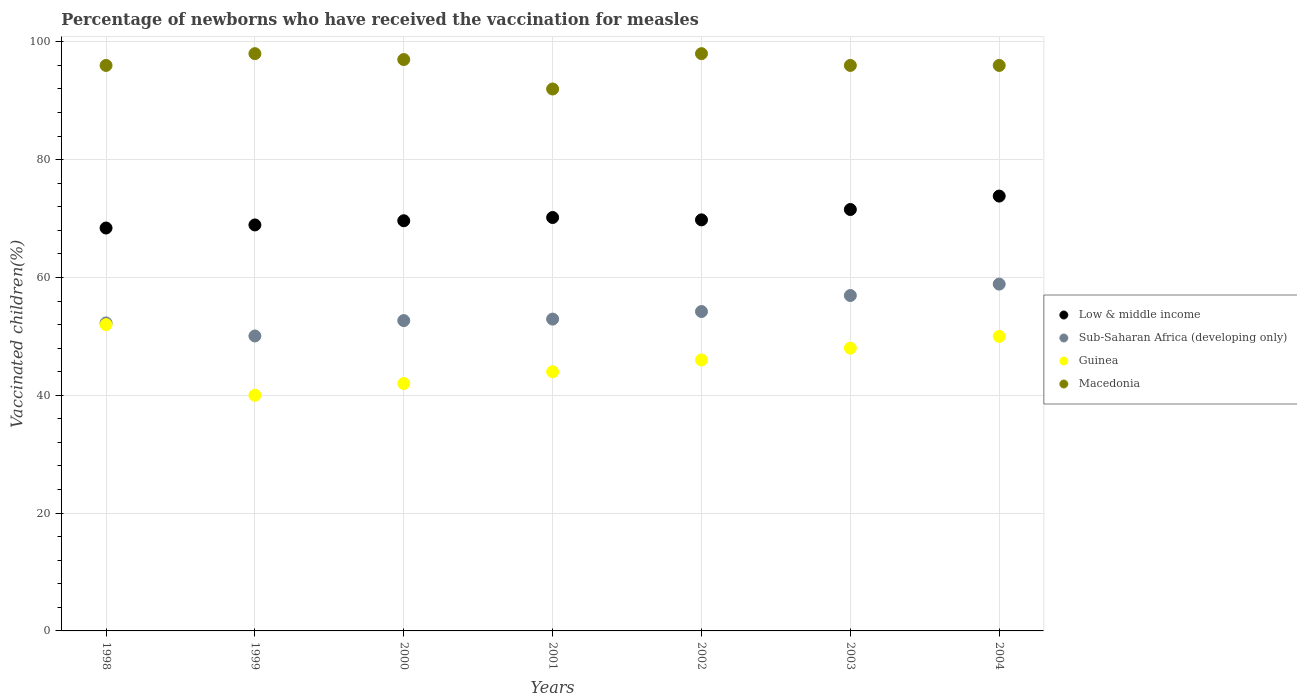How many different coloured dotlines are there?
Ensure brevity in your answer.  4. Is the number of dotlines equal to the number of legend labels?
Keep it short and to the point. Yes. What is the percentage of vaccinated children in Sub-Saharan Africa (developing only) in 1998?
Offer a very short reply. 52.28. Across all years, what is the maximum percentage of vaccinated children in Low & middle income?
Offer a very short reply. 73.82. Across all years, what is the minimum percentage of vaccinated children in Macedonia?
Your answer should be very brief. 92. What is the total percentage of vaccinated children in Sub-Saharan Africa (developing only) in the graph?
Offer a terse response. 378.02. What is the difference between the percentage of vaccinated children in Sub-Saharan Africa (developing only) in 1998 and that in 2000?
Your answer should be compact. -0.4. What is the difference between the percentage of vaccinated children in Guinea in 2004 and the percentage of vaccinated children in Sub-Saharan Africa (developing only) in 2001?
Your answer should be compact. -2.94. In the year 2004, what is the difference between the percentage of vaccinated children in Guinea and percentage of vaccinated children in Sub-Saharan Africa (developing only)?
Provide a short and direct response. -8.88. What is the ratio of the percentage of vaccinated children in Sub-Saharan Africa (developing only) in 2000 to that in 2001?
Offer a very short reply. 1. Is the difference between the percentage of vaccinated children in Guinea in 2000 and 2003 greater than the difference between the percentage of vaccinated children in Sub-Saharan Africa (developing only) in 2000 and 2003?
Your answer should be very brief. No. What is the difference between the highest and the lowest percentage of vaccinated children in Guinea?
Provide a short and direct response. 12. In how many years, is the percentage of vaccinated children in Guinea greater than the average percentage of vaccinated children in Guinea taken over all years?
Provide a short and direct response. 3. Is it the case that in every year, the sum of the percentage of vaccinated children in Sub-Saharan Africa (developing only) and percentage of vaccinated children in Guinea  is greater than the percentage of vaccinated children in Macedonia?
Your answer should be compact. No. Does the percentage of vaccinated children in Sub-Saharan Africa (developing only) monotonically increase over the years?
Your answer should be very brief. No. Is the percentage of vaccinated children in Sub-Saharan Africa (developing only) strictly greater than the percentage of vaccinated children in Low & middle income over the years?
Your answer should be compact. No. Is the percentage of vaccinated children in Guinea strictly less than the percentage of vaccinated children in Low & middle income over the years?
Your response must be concise. Yes. Are the values on the major ticks of Y-axis written in scientific E-notation?
Provide a short and direct response. No. Does the graph contain grids?
Offer a very short reply. Yes. Where does the legend appear in the graph?
Offer a very short reply. Center right. How many legend labels are there?
Provide a succinct answer. 4. What is the title of the graph?
Make the answer very short. Percentage of newborns who have received the vaccination for measles. What is the label or title of the X-axis?
Keep it short and to the point. Years. What is the label or title of the Y-axis?
Give a very brief answer. Vaccinated children(%). What is the Vaccinated children(%) in Low & middle income in 1998?
Make the answer very short. 68.4. What is the Vaccinated children(%) of Sub-Saharan Africa (developing only) in 1998?
Provide a short and direct response. 52.28. What is the Vaccinated children(%) of Guinea in 1998?
Give a very brief answer. 52. What is the Vaccinated children(%) in Macedonia in 1998?
Offer a very short reply. 96. What is the Vaccinated children(%) of Low & middle income in 1999?
Offer a very short reply. 68.92. What is the Vaccinated children(%) in Sub-Saharan Africa (developing only) in 1999?
Your answer should be compact. 50.07. What is the Vaccinated children(%) of Low & middle income in 2000?
Give a very brief answer. 69.63. What is the Vaccinated children(%) in Sub-Saharan Africa (developing only) in 2000?
Offer a terse response. 52.68. What is the Vaccinated children(%) of Guinea in 2000?
Provide a succinct answer. 42. What is the Vaccinated children(%) of Macedonia in 2000?
Your answer should be compact. 97. What is the Vaccinated children(%) of Low & middle income in 2001?
Give a very brief answer. 70.18. What is the Vaccinated children(%) of Sub-Saharan Africa (developing only) in 2001?
Make the answer very short. 52.94. What is the Vaccinated children(%) of Guinea in 2001?
Provide a short and direct response. 44. What is the Vaccinated children(%) in Macedonia in 2001?
Your response must be concise. 92. What is the Vaccinated children(%) of Low & middle income in 2002?
Make the answer very short. 69.78. What is the Vaccinated children(%) of Sub-Saharan Africa (developing only) in 2002?
Give a very brief answer. 54.22. What is the Vaccinated children(%) in Guinea in 2002?
Offer a terse response. 46. What is the Vaccinated children(%) in Macedonia in 2002?
Ensure brevity in your answer.  98. What is the Vaccinated children(%) of Low & middle income in 2003?
Offer a terse response. 71.54. What is the Vaccinated children(%) in Sub-Saharan Africa (developing only) in 2003?
Offer a very short reply. 56.94. What is the Vaccinated children(%) in Macedonia in 2003?
Provide a succinct answer. 96. What is the Vaccinated children(%) of Low & middle income in 2004?
Your response must be concise. 73.82. What is the Vaccinated children(%) in Sub-Saharan Africa (developing only) in 2004?
Offer a terse response. 58.88. What is the Vaccinated children(%) in Macedonia in 2004?
Offer a very short reply. 96. Across all years, what is the maximum Vaccinated children(%) in Low & middle income?
Keep it short and to the point. 73.82. Across all years, what is the maximum Vaccinated children(%) in Sub-Saharan Africa (developing only)?
Offer a terse response. 58.88. Across all years, what is the minimum Vaccinated children(%) in Low & middle income?
Your response must be concise. 68.4. Across all years, what is the minimum Vaccinated children(%) of Sub-Saharan Africa (developing only)?
Offer a terse response. 50.07. Across all years, what is the minimum Vaccinated children(%) of Guinea?
Your answer should be very brief. 40. Across all years, what is the minimum Vaccinated children(%) in Macedonia?
Keep it short and to the point. 92. What is the total Vaccinated children(%) of Low & middle income in the graph?
Your answer should be compact. 492.29. What is the total Vaccinated children(%) in Sub-Saharan Africa (developing only) in the graph?
Provide a succinct answer. 378.02. What is the total Vaccinated children(%) in Guinea in the graph?
Make the answer very short. 322. What is the total Vaccinated children(%) of Macedonia in the graph?
Your response must be concise. 673. What is the difference between the Vaccinated children(%) in Low & middle income in 1998 and that in 1999?
Your answer should be compact. -0.52. What is the difference between the Vaccinated children(%) of Sub-Saharan Africa (developing only) in 1998 and that in 1999?
Offer a terse response. 2.21. What is the difference between the Vaccinated children(%) of Macedonia in 1998 and that in 1999?
Ensure brevity in your answer.  -2. What is the difference between the Vaccinated children(%) of Low & middle income in 1998 and that in 2000?
Provide a short and direct response. -1.23. What is the difference between the Vaccinated children(%) in Sub-Saharan Africa (developing only) in 1998 and that in 2000?
Make the answer very short. -0.4. What is the difference between the Vaccinated children(%) in Guinea in 1998 and that in 2000?
Provide a succinct answer. 10. What is the difference between the Vaccinated children(%) in Low & middle income in 1998 and that in 2001?
Provide a short and direct response. -1.78. What is the difference between the Vaccinated children(%) of Sub-Saharan Africa (developing only) in 1998 and that in 2001?
Your response must be concise. -0.65. What is the difference between the Vaccinated children(%) of Macedonia in 1998 and that in 2001?
Make the answer very short. 4. What is the difference between the Vaccinated children(%) of Low & middle income in 1998 and that in 2002?
Make the answer very short. -1.38. What is the difference between the Vaccinated children(%) in Sub-Saharan Africa (developing only) in 1998 and that in 2002?
Your answer should be very brief. -1.94. What is the difference between the Vaccinated children(%) in Low & middle income in 1998 and that in 2003?
Ensure brevity in your answer.  -3.14. What is the difference between the Vaccinated children(%) in Sub-Saharan Africa (developing only) in 1998 and that in 2003?
Offer a very short reply. -4.66. What is the difference between the Vaccinated children(%) in Guinea in 1998 and that in 2003?
Provide a succinct answer. 4. What is the difference between the Vaccinated children(%) of Macedonia in 1998 and that in 2003?
Provide a short and direct response. 0. What is the difference between the Vaccinated children(%) in Low & middle income in 1998 and that in 2004?
Ensure brevity in your answer.  -5.42. What is the difference between the Vaccinated children(%) of Sub-Saharan Africa (developing only) in 1998 and that in 2004?
Offer a terse response. -6.59. What is the difference between the Vaccinated children(%) in Low & middle income in 1999 and that in 2000?
Ensure brevity in your answer.  -0.71. What is the difference between the Vaccinated children(%) in Sub-Saharan Africa (developing only) in 1999 and that in 2000?
Offer a very short reply. -2.61. What is the difference between the Vaccinated children(%) of Low & middle income in 1999 and that in 2001?
Your answer should be compact. -1.26. What is the difference between the Vaccinated children(%) of Sub-Saharan Africa (developing only) in 1999 and that in 2001?
Ensure brevity in your answer.  -2.87. What is the difference between the Vaccinated children(%) in Guinea in 1999 and that in 2001?
Your answer should be very brief. -4. What is the difference between the Vaccinated children(%) in Low & middle income in 1999 and that in 2002?
Make the answer very short. -0.86. What is the difference between the Vaccinated children(%) of Sub-Saharan Africa (developing only) in 1999 and that in 2002?
Provide a succinct answer. -4.15. What is the difference between the Vaccinated children(%) of Low & middle income in 1999 and that in 2003?
Offer a terse response. -2.62. What is the difference between the Vaccinated children(%) in Sub-Saharan Africa (developing only) in 1999 and that in 2003?
Provide a short and direct response. -6.87. What is the difference between the Vaccinated children(%) of Guinea in 1999 and that in 2003?
Your response must be concise. -8. What is the difference between the Vaccinated children(%) in Macedonia in 1999 and that in 2003?
Your response must be concise. 2. What is the difference between the Vaccinated children(%) in Low & middle income in 1999 and that in 2004?
Your answer should be very brief. -4.9. What is the difference between the Vaccinated children(%) of Sub-Saharan Africa (developing only) in 1999 and that in 2004?
Make the answer very short. -8.81. What is the difference between the Vaccinated children(%) in Macedonia in 1999 and that in 2004?
Offer a terse response. 2. What is the difference between the Vaccinated children(%) of Low & middle income in 2000 and that in 2001?
Your answer should be very brief. -0.55. What is the difference between the Vaccinated children(%) of Sub-Saharan Africa (developing only) in 2000 and that in 2001?
Your response must be concise. -0.25. What is the difference between the Vaccinated children(%) in Guinea in 2000 and that in 2001?
Offer a terse response. -2. What is the difference between the Vaccinated children(%) in Low & middle income in 2000 and that in 2002?
Offer a very short reply. -0.15. What is the difference between the Vaccinated children(%) in Sub-Saharan Africa (developing only) in 2000 and that in 2002?
Keep it short and to the point. -1.54. What is the difference between the Vaccinated children(%) in Low & middle income in 2000 and that in 2003?
Give a very brief answer. -1.91. What is the difference between the Vaccinated children(%) in Sub-Saharan Africa (developing only) in 2000 and that in 2003?
Make the answer very short. -4.25. What is the difference between the Vaccinated children(%) in Guinea in 2000 and that in 2003?
Provide a short and direct response. -6. What is the difference between the Vaccinated children(%) in Low & middle income in 2000 and that in 2004?
Your response must be concise. -4.19. What is the difference between the Vaccinated children(%) of Sub-Saharan Africa (developing only) in 2000 and that in 2004?
Your answer should be compact. -6.19. What is the difference between the Vaccinated children(%) of Guinea in 2000 and that in 2004?
Your response must be concise. -8. What is the difference between the Vaccinated children(%) of Macedonia in 2000 and that in 2004?
Your answer should be very brief. 1. What is the difference between the Vaccinated children(%) in Low & middle income in 2001 and that in 2002?
Give a very brief answer. 0.4. What is the difference between the Vaccinated children(%) in Sub-Saharan Africa (developing only) in 2001 and that in 2002?
Offer a very short reply. -1.28. What is the difference between the Vaccinated children(%) of Macedonia in 2001 and that in 2002?
Offer a very short reply. -6. What is the difference between the Vaccinated children(%) in Low & middle income in 2001 and that in 2003?
Your answer should be compact. -1.36. What is the difference between the Vaccinated children(%) in Sub-Saharan Africa (developing only) in 2001 and that in 2003?
Keep it short and to the point. -4. What is the difference between the Vaccinated children(%) of Macedonia in 2001 and that in 2003?
Your response must be concise. -4. What is the difference between the Vaccinated children(%) of Low & middle income in 2001 and that in 2004?
Provide a short and direct response. -3.64. What is the difference between the Vaccinated children(%) in Sub-Saharan Africa (developing only) in 2001 and that in 2004?
Your answer should be compact. -5.94. What is the difference between the Vaccinated children(%) of Macedonia in 2001 and that in 2004?
Your response must be concise. -4. What is the difference between the Vaccinated children(%) of Low & middle income in 2002 and that in 2003?
Make the answer very short. -1.76. What is the difference between the Vaccinated children(%) in Sub-Saharan Africa (developing only) in 2002 and that in 2003?
Provide a short and direct response. -2.72. What is the difference between the Vaccinated children(%) in Guinea in 2002 and that in 2003?
Your response must be concise. -2. What is the difference between the Vaccinated children(%) of Macedonia in 2002 and that in 2003?
Keep it short and to the point. 2. What is the difference between the Vaccinated children(%) of Low & middle income in 2002 and that in 2004?
Keep it short and to the point. -4.04. What is the difference between the Vaccinated children(%) of Sub-Saharan Africa (developing only) in 2002 and that in 2004?
Provide a succinct answer. -4.66. What is the difference between the Vaccinated children(%) in Guinea in 2002 and that in 2004?
Ensure brevity in your answer.  -4. What is the difference between the Vaccinated children(%) in Low & middle income in 2003 and that in 2004?
Provide a succinct answer. -2.28. What is the difference between the Vaccinated children(%) of Sub-Saharan Africa (developing only) in 2003 and that in 2004?
Give a very brief answer. -1.94. What is the difference between the Vaccinated children(%) of Macedonia in 2003 and that in 2004?
Provide a short and direct response. 0. What is the difference between the Vaccinated children(%) of Low & middle income in 1998 and the Vaccinated children(%) of Sub-Saharan Africa (developing only) in 1999?
Your answer should be very brief. 18.33. What is the difference between the Vaccinated children(%) of Low & middle income in 1998 and the Vaccinated children(%) of Guinea in 1999?
Give a very brief answer. 28.4. What is the difference between the Vaccinated children(%) in Low & middle income in 1998 and the Vaccinated children(%) in Macedonia in 1999?
Offer a terse response. -29.6. What is the difference between the Vaccinated children(%) of Sub-Saharan Africa (developing only) in 1998 and the Vaccinated children(%) of Guinea in 1999?
Your answer should be very brief. 12.28. What is the difference between the Vaccinated children(%) of Sub-Saharan Africa (developing only) in 1998 and the Vaccinated children(%) of Macedonia in 1999?
Your answer should be very brief. -45.72. What is the difference between the Vaccinated children(%) of Guinea in 1998 and the Vaccinated children(%) of Macedonia in 1999?
Give a very brief answer. -46. What is the difference between the Vaccinated children(%) in Low & middle income in 1998 and the Vaccinated children(%) in Sub-Saharan Africa (developing only) in 2000?
Ensure brevity in your answer.  15.71. What is the difference between the Vaccinated children(%) of Low & middle income in 1998 and the Vaccinated children(%) of Guinea in 2000?
Your response must be concise. 26.4. What is the difference between the Vaccinated children(%) of Low & middle income in 1998 and the Vaccinated children(%) of Macedonia in 2000?
Offer a very short reply. -28.6. What is the difference between the Vaccinated children(%) of Sub-Saharan Africa (developing only) in 1998 and the Vaccinated children(%) of Guinea in 2000?
Provide a short and direct response. 10.28. What is the difference between the Vaccinated children(%) in Sub-Saharan Africa (developing only) in 1998 and the Vaccinated children(%) in Macedonia in 2000?
Offer a very short reply. -44.72. What is the difference between the Vaccinated children(%) of Guinea in 1998 and the Vaccinated children(%) of Macedonia in 2000?
Offer a very short reply. -45. What is the difference between the Vaccinated children(%) of Low & middle income in 1998 and the Vaccinated children(%) of Sub-Saharan Africa (developing only) in 2001?
Make the answer very short. 15.46. What is the difference between the Vaccinated children(%) in Low & middle income in 1998 and the Vaccinated children(%) in Guinea in 2001?
Keep it short and to the point. 24.4. What is the difference between the Vaccinated children(%) of Low & middle income in 1998 and the Vaccinated children(%) of Macedonia in 2001?
Provide a short and direct response. -23.6. What is the difference between the Vaccinated children(%) of Sub-Saharan Africa (developing only) in 1998 and the Vaccinated children(%) of Guinea in 2001?
Your answer should be very brief. 8.28. What is the difference between the Vaccinated children(%) in Sub-Saharan Africa (developing only) in 1998 and the Vaccinated children(%) in Macedonia in 2001?
Provide a succinct answer. -39.72. What is the difference between the Vaccinated children(%) of Low & middle income in 1998 and the Vaccinated children(%) of Sub-Saharan Africa (developing only) in 2002?
Offer a terse response. 14.18. What is the difference between the Vaccinated children(%) of Low & middle income in 1998 and the Vaccinated children(%) of Guinea in 2002?
Offer a terse response. 22.4. What is the difference between the Vaccinated children(%) of Low & middle income in 1998 and the Vaccinated children(%) of Macedonia in 2002?
Offer a very short reply. -29.6. What is the difference between the Vaccinated children(%) of Sub-Saharan Africa (developing only) in 1998 and the Vaccinated children(%) of Guinea in 2002?
Make the answer very short. 6.28. What is the difference between the Vaccinated children(%) in Sub-Saharan Africa (developing only) in 1998 and the Vaccinated children(%) in Macedonia in 2002?
Provide a succinct answer. -45.72. What is the difference between the Vaccinated children(%) of Guinea in 1998 and the Vaccinated children(%) of Macedonia in 2002?
Your response must be concise. -46. What is the difference between the Vaccinated children(%) in Low & middle income in 1998 and the Vaccinated children(%) in Sub-Saharan Africa (developing only) in 2003?
Keep it short and to the point. 11.46. What is the difference between the Vaccinated children(%) in Low & middle income in 1998 and the Vaccinated children(%) in Guinea in 2003?
Provide a short and direct response. 20.4. What is the difference between the Vaccinated children(%) of Low & middle income in 1998 and the Vaccinated children(%) of Macedonia in 2003?
Ensure brevity in your answer.  -27.6. What is the difference between the Vaccinated children(%) in Sub-Saharan Africa (developing only) in 1998 and the Vaccinated children(%) in Guinea in 2003?
Offer a very short reply. 4.28. What is the difference between the Vaccinated children(%) of Sub-Saharan Africa (developing only) in 1998 and the Vaccinated children(%) of Macedonia in 2003?
Offer a very short reply. -43.72. What is the difference between the Vaccinated children(%) in Guinea in 1998 and the Vaccinated children(%) in Macedonia in 2003?
Give a very brief answer. -44. What is the difference between the Vaccinated children(%) in Low & middle income in 1998 and the Vaccinated children(%) in Sub-Saharan Africa (developing only) in 2004?
Give a very brief answer. 9.52. What is the difference between the Vaccinated children(%) in Low & middle income in 1998 and the Vaccinated children(%) in Guinea in 2004?
Offer a very short reply. 18.4. What is the difference between the Vaccinated children(%) in Low & middle income in 1998 and the Vaccinated children(%) in Macedonia in 2004?
Provide a short and direct response. -27.6. What is the difference between the Vaccinated children(%) of Sub-Saharan Africa (developing only) in 1998 and the Vaccinated children(%) of Guinea in 2004?
Your answer should be compact. 2.28. What is the difference between the Vaccinated children(%) in Sub-Saharan Africa (developing only) in 1998 and the Vaccinated children(%) in Macedonia in 2004?
Your response must be concise. -43.72. What is the difference between the Vaccinated children(%) in Guinea in 1998 and the Vaccinated children(%) in Macedonia in 2004?
Keep it short and to the point. -44. What is the difference between the Vaccinated children(%) of Low & middle income in 1999 and the Vaccinated children(%) of Sub-Saharan Africa (developing only) in 2000?
Make the answer very short. 16.24. What is the difference between the Vaccinated children(%) of Low & middle income in 1999 and the Vaccinated children(%) of Guinea in 2000?
Your response must be concise. 26.92. What is the difference between the Vaccinated children(%) in Low & middle income in 1999 and the Vaccinated children(%) in Macedonia in 2000?
Offer a very short reply. -28.08. What is the difference between the Vaccinated children(%) of Sub-Saharan Africa (developing only) in 1999 and the Vaccinated children(%) of Guinea in 2000?
Your response must be concise. 8.07. What is the difference between the Vaccinated children(%) in Sub-Saharan Africa (developing only) in 1999 and the Vaccinated children(%) in Macedonia in 2000?
Provide a succinct answer. -46.93. What is the difference between the Vaccinated children(%) in Guinea in 1999 and the Vaccinated children(%) in Macedonia in 2000?
Your answer should be very brief. -57. What is the difference between the Vaccinated children(%) of Low & middle income in 1999 and the Vaccinated children(%) of Sub-Saharan Africa (developing only) in 2001?
Your answer should be very brief. 15.99. What is the difference between the Vaccinated children(%) in Low & middle income in 1999 and the Vaccinated children(%) in Guinea in 2001?
Provide a succinct answer. 24.92. What is the difference between the Vaccinated children(%) in Low & middle income in 1999 and the Vaccinated children(%) in Macedonia in 2001?
Your answer should be compact. -23.08. What is the difference between the Vaccinated children(%) of Sub-Saharan Africa (developing only) in 1999 and the Vaccinated children(%) of Guinea in 2001?
Give a very brief answer. 6.07. What is the difference between the Vaccinated children(%) in Sub-Saharan Africa (developing only) in 1999 and the Vaccinated children(%) in Macedonia in 2001?
Your answer should be compact. -41.93. What is the difference between the Vaccinated children(%) in Guinea in 1999 and the Vaccinated children(%) in Macedonia in 2001?
Offer a terse response. -52. What is the difference between the Vaccinated children(%) in Low & middle income in 1999 and the Vaccinated children(%) in Sub-Saharan Africa (developing only) in 2002?
Your answer should be compact. 14.7. What is the difference between the Vaccinated children(%) of Low & middle income in 1999 and the Vaccinated children(%) of Guinea in 2002?
Keep it short and to the point. 22.92. What is the difference between the Vaccinated children(%) in Low & middle income in 1999 and the Vaccinated children(%) in Macedonia in 2002?
Offer a very short reply. -29.08. What is the difference between the Vaccinated children(%) in Sub-Saharan Africa (developing only) in 1999 and the Vaccinated children(%) in Guinea in 2002?
Provide a short and direct response. 4.07. What is the difference between the Vaccinated children(%) in Sub-Saharan Africa (developing only) in 1999 and the Vaccinated children(%) in Macedonia in 2002?
Keep it short and to the point. -47.93. What is the difference between the Vaccinated children(%) in Guinea in 1999 and the Vaccinated children(%) in Macedonia in 2002?
Keep it short and to the point. -58. What is the difference between the Vaccinated children(%) of Low & middle income in 1999 and the Vaccinated children(%) of Sub-Saharan Africa (developing only) in 2003?
Provide a succinct answer. 11.98. What is the difference between the Vaccinated children(%) of Low & middle income in 1999 and the Vaccinated children(%) of Guinea in 2003?
Your response must be concise. 20.92. What is the difference between the Vaccinated children(%) in Low & middle income in 1999 and the Vaccinated children(%) in Macedonia in 2003?
Your response must be concise. -27.08. What is the difference between the Vaccinated children(%) in Sub-Saharan Africa (developing only) in 1999 and the Vaccinated children(%) in Guinea in 2003?
Your answer should be compact. 2.07. What is the difference between the Vaccinated children(%) in Sub-Saharan Africa (developing only) in 1999 and the Vaccinated children(%) in Macedonia in 2003?
Ensure brevity in your answer.  -45.93. What is the difference between the Vaccinated children(%) of Guinea in 1999 and the Vaccinated children(%) of Macedonia in 2003?
Your answer should be very brief. -56. What is the difference between the Vaccinated children(%) in Low & middle income in 1999 and the Vaccinated children(%) in Sub-Saharan Africa (developing only) in 2004?
Your answer should be very brief. 10.05. What is the difference between the Vaccinated children(%) in Low & middle income in 1999 and the Vaccinated children(%) in Guinea in 2004?
Ensure brevity in your answer.  18.92. What is the difference between the Vaccinated children(%) of Low & middle income in 1999 and the Vaccinated children(%) of Macedonia in 2004?
Make the answer very short. -27.08. What is the difference between the Vaccinated children(%) of Sub-Saharan Africa (developing only) in 1999 and the Vaccinated children(%) of Guinea in 2004?
Your answer should be very brief. 0.07. What is the difference between the Vaccinated children(%) in Sub-Saharan Africa (developing only) in 1999 and the Vaccinated children(%) in Macedonia in 2004?
Ensure brevity in your answer.  -45.93. What is the difference between the Vaccinated children(%) in Guinea in 1999 and the Vaccinated children(%) in Macedonia in 2004?
Offer a terse response. -56. What is the difference between the Vaccinated children(%) of Low & middle income in 2000 and the Vaccinated children(%) of Sub-Saharan Africa (developing only) in 2001?
Give a very brief answer. 16.7. What is the difference between the Vaccinated children(%) of Low & middle income in 2000 and the Vaccinated children(%) of Guinea in 2001?
Provide a short and direct response. 25.63. What is the difference between the Vaccinated children(%) of Low & middle income in 2000 and the Vaccinated children(%) of Macedonia in 2001?
Ensure brevity in your answer.  -22.37. What is the difference between the Vaccinated children(%) in Sub-Saharan Africa (developing only) in 2000 and the Vaccinated children(%) in Guinea in 2001?
Your answer should be compact. 8.68. What is the difference between the Vaccinated children(%) of Sub-Saharan Africa (developing only) in 2000 and the Vaccinated children(%) of Macedonia in 2001?
Offer a terse response. -39.32. What is the difference between the Vaccinated children(%) of Guinea in 2000 and the Vaccinated children(%) of Macedonia in 2001?
Give a very brief answer. -50. What is the difference between the Vaccinated children(%) in Low & middle income in 2000 and the Vaccinated children(%) in Sub-Saharan Africa (developing only) in 2002?
Offer a terse response. 15.41. What is the difference between the Vaccinated children(%) in Low & middle income in 2000 and the Vaccinated children(%) in Guinea in 2002?
Keep it short and to the point. 23.63. What is the difference between the Vaccinated children(%) of Low & middle income in 2000 and the Vaccinated children(%) of Macedonia in 2002?
Keep it short and to the point. -28.37. What is the difference between the Vaccinated children(%) of Sub-Saharan Africa (developing only) in 2000 and the Vaccinated children(%) of Guinea in 2002?
Your answer should be very brief. 6.68. What is the difference between the Vaccinated children(%) in Sub-Saharan Africa (developing only) in 2000 and the Vaccinated children(%) in Macedonia in 2002?
Ensure brevity in your answer.  -45.32. What is the difference between the Vaccinated children(%) of Guinea in 2000 and the Vaccinated children(%) of Macedonia in 2002?
Make the answer very short. -56. What is the difference between the Vaccinated children(%) of Low & middle income in 2000 and the Vaccinated children(%) of Sub-Saharan Africa (developing only) in 2003?
Give a very brief answer. 12.69. What is the difference between the Vaccinated children(%) in Low & middle income in 2000 and the Vaccinated children(%) in Guinea in 2003?
Make the answer very short. 21.63. What is the difference between the Vaccinated children(%) in Low & middle income in 2000 and the Vaccinated children(%) in Macedonia in 2003?
Ensure brevity in your answer.  -26.37. What is the difference between the Vaccinated children(%) in Sub-Saharan Africa (developing only) in 2000 and the Vaccinated children(%) in Guinea in 2003?
Provide a succinct answer. 4.68. What is the difference between the Vaccinated children(%) of Sub-Saharan Africa (developing only) in 2000 and the Vaccinated children(%) of Macedonia in 2003?
Offer a very short reply. -43.32. What is the difference between the Vaccinated children(%) of Guinea in 2000 and the Vaccinated children(%) of Macedonia in 2003?
Your answer should be very brief. -54. What is the difference between the Vaccinated children(%) of Low & middle income in 2000 and the Vaccinated children(%) of Sub-Saharan Africa (developing only) in 2004?
Your answer should be compact. 10.76. What is the difference between the Vaccinated children(%) of Low & middle income in 2000 and the Vaccinated children(%) of Guinea in 2004?
Make the answer very short. 19.63. What is the difference between the Vaccinated children(%) in Low & middle income in 2000 and the Vaccinated children(%) in Macedonia in 2004?
Provide a succinct answer. -26.37. What is the difference between the Vaccinated children(%) of Sub-Saharan Africa (developing only) in 2000 and the Vaccinated children(%) of Guinea in 2004?
Provide a succinct answer. 2.68. What is the difference between the Vaccinated children(%) of Sub-Saharan Africa (developing only) in 2000 and the Vaccinated children(%) of Macedonia in 2004?
Offer a terse response. -43.32. What is the difference between the Vaccinated children(%) of Guinea in 2000 and the Vaccinated children(%) of Macedonia in 2004?
Offer a terse response. -54. What is the difference between the Vaccinated children(%) of Low & middle income in 2001 and the Vaccinated children(%) of Sub-Saharan Africa (developing only) in 2002?
Make the answer very short. 15.96. What is the difference between the Vaccinated children(%) in Low & middle income in 2001 and the Vaccinated children(%) in Guinea in 2002?
Your answer should be compact. 24.18. What is the difference between the Vaccinated children(%) of Low & middle income in 2001 and the Vaccinated children(%) of Macedonia in 2002?
Offer a very short reply. -27.82. What is the difference between the Vaccinated children(%) of Sub-Saharan Africa (developing only) in 2001 and the Vaccinated children(%) of Guinea in 2002?
Provide a succinct answer. 6.94. What is the difference between the Vaccinated children(%) in Sub-Saharan Africa (developing only) in 2001 and the Vaccinated children(%) in Macedonia in 2002?
Your answer should be compact. -45.06. What is the difference between the Vaccinated children(%) of Guinea in 2001 and the Vaccinated children(%) of Macedonia in 2002?
Your response must be concise. -54. What is the difference between the Vaccinated children(%) of Low & middle income in 2001 and the Vaccinated children(%) of Sub-Saharan Africa (developing only) in 2003?
Ensure brevity in your answer.  13.24. What is the difference between the Vaccinated children(%) of Low & middle income in 2001 and the Vaccinated children(%) of Guinea in 2003?
Provide a short and direct response. 22.18. What is the difference between the Vaccinated children(%) of Low & middle income in 2001 and the Vaccinated children(%) of Macedonia in 2003?
Provide a succinct answer. -25.82. What is the difference between the Vaccinated children(%) in Sub-Saharan Africa (developing only) in 2001 and the Vaccinated children(%) in Guinea in 2003?
Your response must be concise. 4.94. What is the difference between the Vaccinated children(%) in Sub-Saharan Africa (developing only) in 2001 and the Vaccinated children(%) in Macedonia in 2003?
Your answer should be compact. -43.06. What is the difference between the Vaccinated children(%) in Guinea in 2001 and the Vaccinated children(%) in Macedonia in 2003?
Offer a very short reply. -52. What is the difference between the Vaccinated children(%) in Low & middle income in 2001 and the Vaccinated children(%) in Sub-Saharan Africa (developing only) in 2004?
Keep it short and to the point. 11.31. What is the difference between the Vaccinated children(%) in Low & middle income in 2001 and the Vaccinated children(%) in Guinea in 2004?
Your answer should be compact. 20.18. What is the difference between the Vaccinated children(%) of Low & middle income in 2001 and the Vaccinated children(%) of Macedonia in 2004?
Ensure brevity in your answer.  -25.82. What is the difference between the Vaccinated children(%) of Sub-Saharan Africa (developing only) in 2001 and the Vaccinated children(%) of Guinea in 2004?
Provide a short and direct response. 2.94. What is the difference between the Vaccinated children(%) of Sub-Saharan Africa (developing only) in 2001 and the Vaccinated children(%) of Macedonia in 2004?
Your answer should be compact. -43.06. What is the difference between the Vaccinated children(%) in Guinea in 2001 and the Vaccinated children(%) in Macedonia in 2004?
Your response must be concise. -52. What is the difference between the Vaccinated children(%) in Low & middle income in 2002 and the Vaccinated children(%) in Sub-Saharan Africa (developing only) in 2003?
Ensure brevity in your answer.  12.84. What is the difference between the Vaccinated children(%) of Low & middle income in 2002 and the Vaccinated children(%) of Guinea in 2003?
Keep it short and to the point. 21.78. What is the difference between the Vaccinated children(%) of Low & middle income in 2002 and the Vaccinated children(%) of Macedonia in 2003?
Offer a terse response. -26.22. What is the difference between the Vaccinated children(%) in Sub-Saharan Africa (developing only) in 2002 and the Vaccinated children(%) in Guinea in 2003?
Keep it short and to the point. 6.22. What is the difference between the Vaccinated children(%) in Sub-Saharan Africa (developing only) in 2002 and the Vaccinated children(%) in Macedonia in 2003?
Your answer should be very brief. -41.78. What is the difference between the Vaccinated children(%) in Guinea in 2002 and the Vaccinated children(%) in Macedonia in 2003?
Ensure brevity in your answer.  -50. What is the difference between the Vaccinated children(%) of Low & middle income in 2002 and the Vaccinated children(%) of Sub-Saharan Africa (developing only) in 2004?
Offer a very short reply. 10.91. What is the difference between the Vaccinated children(%) in Low & middle income in 2002 and the Vaccinated children(%) in Guinea in 2004?
Your answer should be compact. 19.78. What is the difference between the Vaccinated children(%) in Low & middle income in 2002 and the Vaccinated children(%) in Macedonia in 2004?
Keep it short and to the point. -26.22. What is the difference between the Vaccinated children(%) of Sub-Saharan Africa (developing only) in 2002 and the Vaccinated children(%) of Guinea in 2004?
Keep it short and to the point. 4.22. What is the difference between the Vaccinated children(%) in Sub-Saharan Africa (developing only) in 2002 and the Vaccinated children(%) in Macedonia in 2004?
Provide a succinct answer. -41.78. What is the difference between the Vaccinated children(%) of Guinea in 2002 and the Vaccinated children(%) of Macedonia in 2004?
Your response must be concise. -50. What is the difference between the Vaccinated children(%) in Low & middle income in 2003 and the Vaccinated children(%) in Sub-Saharan Africa (developing only) in 2004?
Your answer should be compact. 12.67. What is the difference between the Vaccinated children(%) of Low & middle income in 2003 and the Vaccinated children(%) of Guinea in 2004?
Provide a short and direct response. 21.54. What is the difference between the Vaccinated children(%) in Low & middle income in 2003 and the Vaccinated children(%) in Macedonia in 2004?
Ensure brevity in your answer.  -24.46. What is the difference between the Vaccinated children(%) of Sub-Saharan Africa (developing only) in 2003 and the Vaccinated children(%) of Guinea in 2004?
Your answer should be very brief. 6.94. What is the difference between the Vaccinated children(%) of Sub-Saharan Africa (developing only) in 2003 and the Vaccinated children(%) of Macedonia in 2004?
Offer a terse response. -39.06. What is the difference between the Vaccinated children(%) in Guinea in 2003 and the Vaccinated children(%) in Macedonia in 2004?
Keep it short and to the point. -48. What is the average Vaccinated children(%) in Low & middle income per year?
Provide a succinct answer. 70.33. What is the average Vaccinated children(%) of Sub-Saharan Africa (developing only) per year?
Ensure brevity in your answer.  54. What is the average Vaccinated children(%) in Macedonia per year?
Offer a terse response. 96.14. In the year 1998, what is the difference between the Vaccinated children(%) of Low & middle income and Vaccinated children(%) of Sub-Saharan Africa (developing only)?
Your response must be concise. 16.11. In the year 1998, what is the difference between the Vaccinated children(%) of Low & middle income and Vaccinated children(%) of Guinea?
Give a very brief answer. 16.4. In the year 1998, what is the difference between the Vaccinated children(%) of Low & middle income and Vaccinated children(%) of Macedonia?
Keep it short and to the point. -27.6. In the year 1998, what is the difference between the Vaccinated children(%) in Sub-Saharan Africa (developing only) and Vaccinated children(%) in Guinea?
Your response must be concise. 0.28. In the year 1998, what is the difference between the Vaccinated children(%) of Sub-Saharan Africa (developing only) and Vaccinated children(%) of Macedonia?
Provide a short and direct response. -43.72. In the year 1998, what is the difference between the Vaccinated children(%) of Guinea and Vaccinated children(%) of Macedonia?
Your response must be concise. -44. In the year 1999, what is the difference between the Vaccinated children(%) in Low & middle income and Vaccinated children(%) in Sub-Saharan Africa (developing only)?
Your response must be concise. 18.85. In the year 1999, what is the difference between the Vaccinated children(%) in Low & middle income and Vaccinated children(%) in Guinea?
Your answer should be very brief. 28.92. In the year 1999, what is the difference between the Vaccinated children(%) of Low & middle income and Vaccinated children(%) of Macedonia?
Offer a terse response. -29.08. In the year 1999, what is the difference between the Vaccinated children(%) in Sub-Saharan Africa (developing only) and Vaccinated children(%) in Guinea?
Ensure brevity in your answer.  10.07. In the year 1999, what is the difference between the Vaccinated children(%) in Sub-Saharan Africa (developing only) and Vaccinated children(%) in Macedonia?
Your response must be concise. -47.93. In the year 1999, what is the difference between the Vaccinated children(%) of Guinea and Vaccinated children(%) of Macedonia?
Offer a very short reply. -58. In the year 2000, what is the difference between the Vaccinated children(%) of Low & middle income and Vaccinated children(%) of Sub-Saharan Africa (developing only)?
Offer a very short reply. 16.95. In the year 2000, what is the difference between the Vaccinated children(%) of Low & middle income and Vaccinated children(%) of Guinea?
Ensure brevity in your answer.  27.63. In the year 2000, what is the difference between the Vaccinated children(%) of Low & middle income and Vaccinated children(%) of Macedonia?
Your answer should be very brief. -27.37. In the year 2000, what is the difference between the Vaccinated children(%) of Sub-Saharan Africa (developing only) and Vaccinated children(%) of Guinea?
Ensure brevity in your answer.  10.68. In the year 2000, what is the difference between the Vaccinated children(%) in Sub-Saharan Africa (developing only) and Vaccinated children(%) in Macedonia?
Your answer should be compact. -44.32. In the year 2000, what is the difference between the Vaccinated children(%) in Guinea and Vaccinated children(%) in Macedonia?
Your response must be concise. -55. In the year 2001, what is the difference between the Vaccinated children(%) of Low & middle income and Vaccinated children(%) of Sub-Saharan Africa (developing only)?
Your answer should be compact. 17.25. In the year 2001, what is the difference between the Vaccinated children(%) in Low & middle income and Vaccinated children(%) in Guinea?
Your answer should be compact. 26.18. In the year 2001, what is the difference between the Vaccinated children(%) in Low & middle income and Vaccinated children(%) in Macedonia?
Keep it short and to the point. -21.82. In the year 2001, what is the difference between the Vaccinated children(%) of Sub-Saharan Africa (developing only) and Vaccinated children(%) of Guinea?
Offer a terse response. 8.94. In the year 2001, what is the difference between the Vaccinated children(%) in Sub-Saharan Africa (developing only) and Vaccinated children(%) in Macedonia?
Provide a succinct answer. -39.06. In the year 2001, what is the difference between the Vaccinated children(%) in Guinea and Vaccinated children(%) in Macedonia?
Offer a very short reply. -48. In the year 2002, what is the difference between the Vaccinated children(%) in Low & middle income and Vaccinated children(%) in Sub-Saharan Africa (developing only)?
Make the answer very short. 15.56. In the year 2002, what is the difference between the Vaccinated children(%) in Low & middle income and Vaccinated children(%) in Guinea?
Offer a terse response. 23.78. In the year 2002, what is the difference between the Vaccinated children(%) of Low & middle income and Vaccinated children(%) of Macedonia?
Make the answer very short. -28.22. In the year 2002, what is the difference between the Vaccinated children(%) in Sub-Saharan Africa (developing only) and Vaccinated children(%) in Guinea?
Make the answer very short. 8.22. In the year 2002, what is the difference between the Vaccinated children(%) of Sub-Saharan Africa (developing only) and Vaccinated children(%) of Macedonia?
Give a very brief answer. -43.78. In the year 2002, what is the difference between the Vaccinated children(%) of Guinea and Vaccinated children(%) of Macedonia?
Provide a short and direct response. -52. In the year 2003, what is the difference between the Vaccinated children(%) in Low & middle income and Vaccinated children(%) in Sub-Saharan Africa (developing only)?
Offer a very short reply. 14.6. In the year 2003, what is the difference between the Vaccinated children(%) in Low & middle income and Vaccinated children(%) in Guinea?
Provide a short and direct response. 23.54. In the year 2003, what is the difference between the Vaccinated children(%) in Low & middle income and Vaccinated children(%) in Macedonia?
Ensure brevity in your answer.  -24.46. In the year 2003, what is the difference between the Vaccinated children(%) in Sub-Saharan Africa (developing only) and Vaccinated children(%) in Guinea?
Ensure brevity in your answer.  8.94. In the year 2003, what is the difference between the Vaccinated children(%) in Sub-Saharan Africa (developing only) and Vaccinated children(%) in Macedonia?
Your answer should be compact. -39.06. In the year 2003, what is the difference between the Vaccinated children(%) in Guinea and Vaccinated children(%) in Macedonia?
Ensure brevity in your answer.  -48. In the year 2004, what is the difference between the Vaccinated children(%) of Low & middle income and Vaccinated children(%) of Sub-Saharan Africa (developing only)?
Your response must be concise. 14.95. In the year 2004, what is the difference between the Vaccinated children(%) of Low & middle income and Vaccinated children(%) of Guinea?
Your answer should be compact. 23.82. In the year 2004, what is the difference between the Vaccinated children(%) in Low & middle income and Vaccinated children(%) in Macedonia?
Provide a short and direct response. -22.18. In the year 2004, what is the difference between the Vaccinated children(%) in Sub-Saharan Africa (developing only) and Vaccinated children(%) in Guinea?
Your answer should be very brief. 8.88. In the year 2004, what is the difference between the Vaccinated children(%) in Sub-Saharan Africa (developing only) and Vaccinated children(%) in Macedonia?
Keep it short and to the point. -37.12. In the year 2004, what is the difference between the Vaccinated children(%) of Guinea and Vaccinated children(%) of Macedonia?
Offer a terse response. -46. What is the ratio of the Vaccinated children(%) in Low & middle income in 1998 to that in 1999?
Your response must be concise. 0.99. What is the ratio of the Vaccinated children(%) of Sub-Saharan Africa (developing only) in 1998 to that in 1999?
Ensure brevity in your answer.  1.04. What is the ratio of the Vaccinated children(%) in Macedonia in 1998 to that in 1999?
Keep it short and to the point. 0.98. What is the ratio of the Vaccinated children(%) in Low & middle income in 1998 to that in 2000?
Provide a succinct answer. 0.98. What is the ratio of the Vaccinated children(%) in Guinea in 1998 to that in 2000?
Your response must be concise. 1.24. What is the ratio of the Vaccinated children(%) of Macedonia in 1998 to that in 2000?
Ensure brevity in your answer.  0.99. What is the ratio of the Vaccinated children(%) of Low & middle income in 1998 to that in 2001?
Your answer should be compact. 0.97. What is the ratio of the Vaccinated children(%) of Sub-Saharan Africa (developing only) in 1998 to that in 2001?
Your response must be concise. 0.99. What is the ratio of the Vaccinated children(%) of Guinea in 1998 to that in 2001?
Your response must be concise. 1.18. What is the ratio of the Vaccinated children(%) in Macedonia in 1998 to that in 2001?
Offer a terse response. 1.04. What is the ratio of the Vaccinated children(%) in Low & middle income in 1998 to that in 2002?
Offer a terse response. 0.98. What is the ratio of the Vaccinated children(%) in Sub-Saharan Africa (developing only) in 1998 to that in 2002?
Offer a very short reply. 0.96. What is the ratio of the Vaccinated children(%) in Guinea in 1998 to that in 2002?
Make the answer very short. 1.13. What is the ratio of the Vaccinated children(%) of Macedonia in 1998 to that in 2002?
Offer a terse response. 0.98. What is the ratio of the Vaccinated children(%) of Low & middle income in 1998 to that in 2003?
Provide a short and direct response. 0.96. What is the ratio of the Vaccinated children(%) of Sub-Saharan Africa (developing only) in 1998 to that in 2003?
Make the answer very short. 0.92. What is the ratio of the Vaccinated children(%) in Macedonia in 1998 to that in 2003?
Make the answer very short. 1. What is the ratio of the Vaccinated children(%) in Low & middle income in 1998 to that in 2004?
Provide a short and direct response. 0.93. What is the ratio of the Vaccinated children(%) of Sub-Saharan Africa (developing only) in 1998 to that in 2004?
Your response must be concise. 0.89. What is the ratio of the Vaccinated children(%) of Macedonia in 1998 to that in 2004?
Provide a succinct answer. 1. What is the ratio of the Vaccinated children(%) of Sub-Saharan Africa (developing only) in 1999 to that in 2000?
Provide a succinct answer. 0.95. What is the ratio of the Vaccinated children(%) of Macedonia in 1999 to that in 2000?
Your answer should be very brief. 1.01. What is the ratio of the Vaccinated children(%) in Sub-Saharan Africa (developing only) in 1999 to that in 2001?
Your response must be concise. 0.95. What is the ratio of the Vaccinated children(%) of Macedonia in 1999 to that in 2001?
Your answer should be very brief. 1.07. What is the ratio of the Vaccinated children(%) of Low & middle income in 1999 to that in 2002?
Keep it short and to the point. 0.99. What is the ratio of the Vaccinated children(%) in Sub-Saharan Africa (developing only) in 1999 to that in 2002?
Offer a terse response. 0.92. What is the ratio of the Vaccinated children(%) of Guinea in 1999 to that in 2002?
Your answer should be very brief. 0.87. What is the ratio of the Vaccinated children(%) of Macedonia in 1999 to that in 2002?
Provide a short and direct response. 1. What is the ratio of the Vaccinated children(%) in Low & middle income in 1999 to that in 2003?
Offer a terse response. 0.96. What is the ratio of the Vaccinated children(%) of Sub-Saharan Africa (developing only) in 1999 to that in 2003?
Provide a short and direct response. 0.88. What is the ratio of the Vaccinated children(%) in Guinea in 1999 to that in 2003?
Keep it short and to the point. 0.83. What is the ratio of the Vaccinated children(%) of Macedonia in 1999 to that in 2003?
Your answer should be very brief. 1.02. What is the ratio of the Vaccinated children(%) of Low & middle income in 1999 to that in 2004?
Ensure brevity in your answer.  0.93. What is the ratio of the Vaccinated children(%) of Sub-Saharan Africa (developing only) in 1999 to that in 2004?
Make the answer very short. 0.85. What is the ratio of the Vaccinated children(%) of Macedonia in 1999 to that in 2004?
Your answer should be compact. 1.02. What is the ratio of the Vaccinated children(%) in Low & middle income in 2000 to that in 2001?
Offer a very short reply. 0.99. What is the ratio of the Vaccinated children(%) in Sub-Saharan Africa (developing only) in 2000 to that in 2001?
Provide a short and direct response. 1. What is the ratio of the Vaccinated children(%) in Guinea in 2000 to that in 2001?
Provide a short and direct response. 0.95. What is the ratio of the Vaccinated children(%) of Macedonia in 2000 to that in 2001?
Provide a short and direct response. 1.05. What is the ratio of the Vaccinated children(%) in Low & middle income in 2000 to that in 2002?
Your answer should be compact. 1. What is the ratio of the Vaccinated children(%) in Sub-Saharan Africa (developing only) in 2000 to that in 2002?
Offer a very short reply. 0.97. What is the ratio of the Vaccinated children(%) of Macedonia in 2000 to that in 2002?
Make the answer very short. 0.99. What is the ratio of the Vaccinated children(%) in Low & middle income in 2000 to that in 2003?
Keep it short and to the point. 0.97. What is the ratio of the Vaccinated children(%) of Sub-Saharan Africa (developing only) in 2000 to that in 2003?
Your response must be concise. 0.93. What is the ratio of the Vaccinated children(%) in Guinea in 2000 to that in 2003?
Your answer should be compact. 0.88. What is the ratio of the Vaccinated children(%) of Macedonia in 2000 to that in 2003?
Make the answer very short. 1.01. What is the ratio of the Vaccinated children(%) of Low & middle income in 2000 to that in 2004?
Keep it short and to the point. 0.94. What is the ratio of the Vaccinated children(%) in Sub-Saharan Africa (developing only) in 2000 to that in 2004?
Provide a succinct answer. 0.89. What is the ratio of the Vaccinated children(%) in Guinea in 2000 to that in 2004?
Your answer should be very brief. 0.84. What is the ratio of the Vaccinated children(%) of Macedonia in 2000 to that in 2004?
Ensure brevity in your answer.  1.01. What is the ratio of the Vaccinated children(%) in Low & middle income in 2001 to that in 2002?
Provide a succinct answer. 1.01. What is the ratio of the Vaccinated children(%) of Sub-Saharan Africa (developing only) in 2001 to that in 2002?
Provide a short and direct response. 0.98. What is the ratio of the Vaccinated children(%) of Guinea in 2001 to that in 2002?
Ensure brevity in your answer.  0.96. What is the ratio of the Vaccinated children(%) of Macedonia in 2001 to that in 2002?
Make the answer very short. 0.94. What is the ratio of the Vaccinated children(%) of Low & middle income in 2001 to that in 2003?
Keep it short and to the point. 0.98. What is the ratio of the Vaccinated children(%) in Sub-Saharan Africa (developing only) in 2001 to that in 2003?
Provide a short and direct response. 0.93. What is the ratio of the Vaccinated children(%) in Guinea in 2001 to that in 2003?
Keep it short and to the point. 0.92. What is the ratio of the Vaccinated children(%) in Macedonia in 2001 to that in 2003?
Your answer should be compact. 0.96. What is the ratio of the Vaccinated children(%) of Low & middle income in 2001 to that in 2004?
Your response must be concise. 0.95. What is the ratio of the Vaccinated children(%) in Sub-Saharan Africa (developing only) in 2001 to that in 2004?
Give a very brief answer. 0.9. What is the ratio of the Vaccinated children(%) in Macedonia in 2001 to that in 2004?
Offer a terse response. 0.96. What is the ratio of the Vaccinated children(%) in Low & middle income in 2002 to that in 2003?
Provide a short and direct response. 0.98. What is the ratio of the Vaccinated children(%) of Sub-Saharan Africa (developing only) in 2002 to that in 2003?
Offer a very short reply. 0.95. What is the ratio of the Vaccinated children(%) in Macedonia in 2002 to that in 2003?
Your answer should be compact. 1.02. What is the ratio of the Vaccinated children(%) in Low & middle income in 2002 to that in 2004?
Offer a terse response. 0.95. What is the ratio of the Vaccinated children(%) in Sub-Saharan Africa (developing only) in 2002 to that in 2004?
Give a very brief answer. 0.92. What is the ratio of the Vaccinated children(%) in Guinea in 2002 to that in 2004?
Ensure brevity in your answer.  0.92. What is the ratio of the Vaccinated children(%) of Macedonia in 2002 to that in 2004?
Your response must be concise. 1.02. What is the ratio of the Vaccinated children(%) of Low & middle income in 2003 to that in 2004?
Your response must be concise. 0.97. What is the ratio of the Vaccinated children(%) of Sub-Saharan Africa (developing only) in 2003 to that in 2004?
Keep it short and to the point. 0.97. What is the ratio of the Vaccinated children(%) of Guinea in 2003 to that in 2004?
Your response must be concise. 0.96. What is the ratio of the Vaccinated children(%) of Macedonia in 2003 to that in 2004?
Provide a short and direct response. 1. What is the difference between the highest and the second highest Vaccinated children(%) of Low & middle income?
Provide a short and direct response. 2.28. What is the difference between the highest and the second highest Vaccinated children(%) of Sub-Saharan Africa (developing only)?
Your answer should be compact. 1.94. What is the difference between the highest and the second highest Vaccinated children(%) in Guinea?
Make the answer very short. 2. What is the difference between the highest and the lowest Vaccinated children(%) in Low & middle income?
Give a very brief answer. 5.42. What is the difference between the highest and the lowest Vaccinated children(%) in Sub-Saharan Africa (developing only)?
Ensure brevity in your answer.  8.81. 